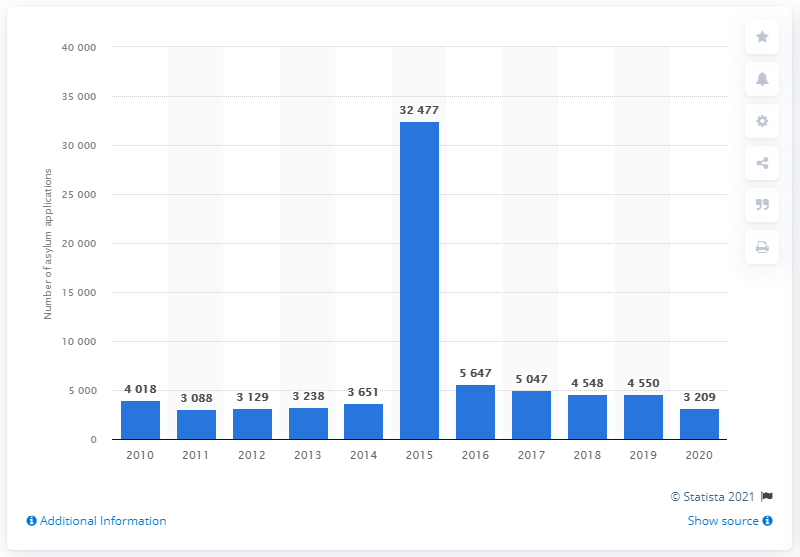Mention a couple of crucial points in this snapshot. In 2015, there were 32,477 asylum applications. The peak number of asylum applications in Finland occurred in 2015. 